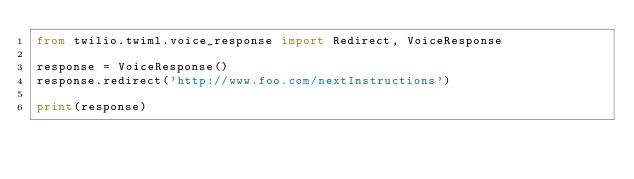Convert code to text. <code><loc_0><loc_0><loc_500><loc_500><_Python_>from twilio.twiml.voice_response import Redirect, VoiceResponse

response = VoiceResponse()
response.redirect('http://www.foo.com/nextInstructions')

print(response)
</code> 